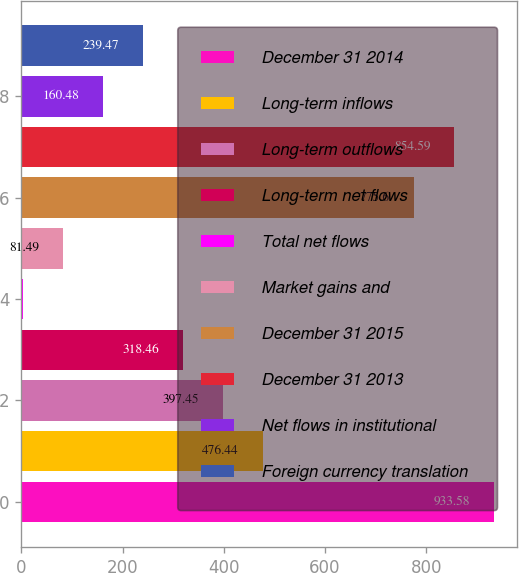Convert chart. <chart><loc_0><loc_0><loc_500><loc_500><bar_chart><fcel>December 31 2014<fcel>Long-term inflows<fcel>Long-term outflows<fcel>Long-term net flows<fcel>Total net flows<fcel>Market gains and<fcel>December 31 2015<fcel>December 31 2013<fcel>Net flows in institutional<fcel>Foreign currency translation<nl><fcel>933.58<fcel>476.44<fcel>397.45<fcel>318.46<fcel>2.5<fcel>81.49<fcel>775.6<fcel>854.59<fcel>160.48<fcel>239.47<nl></chart> 